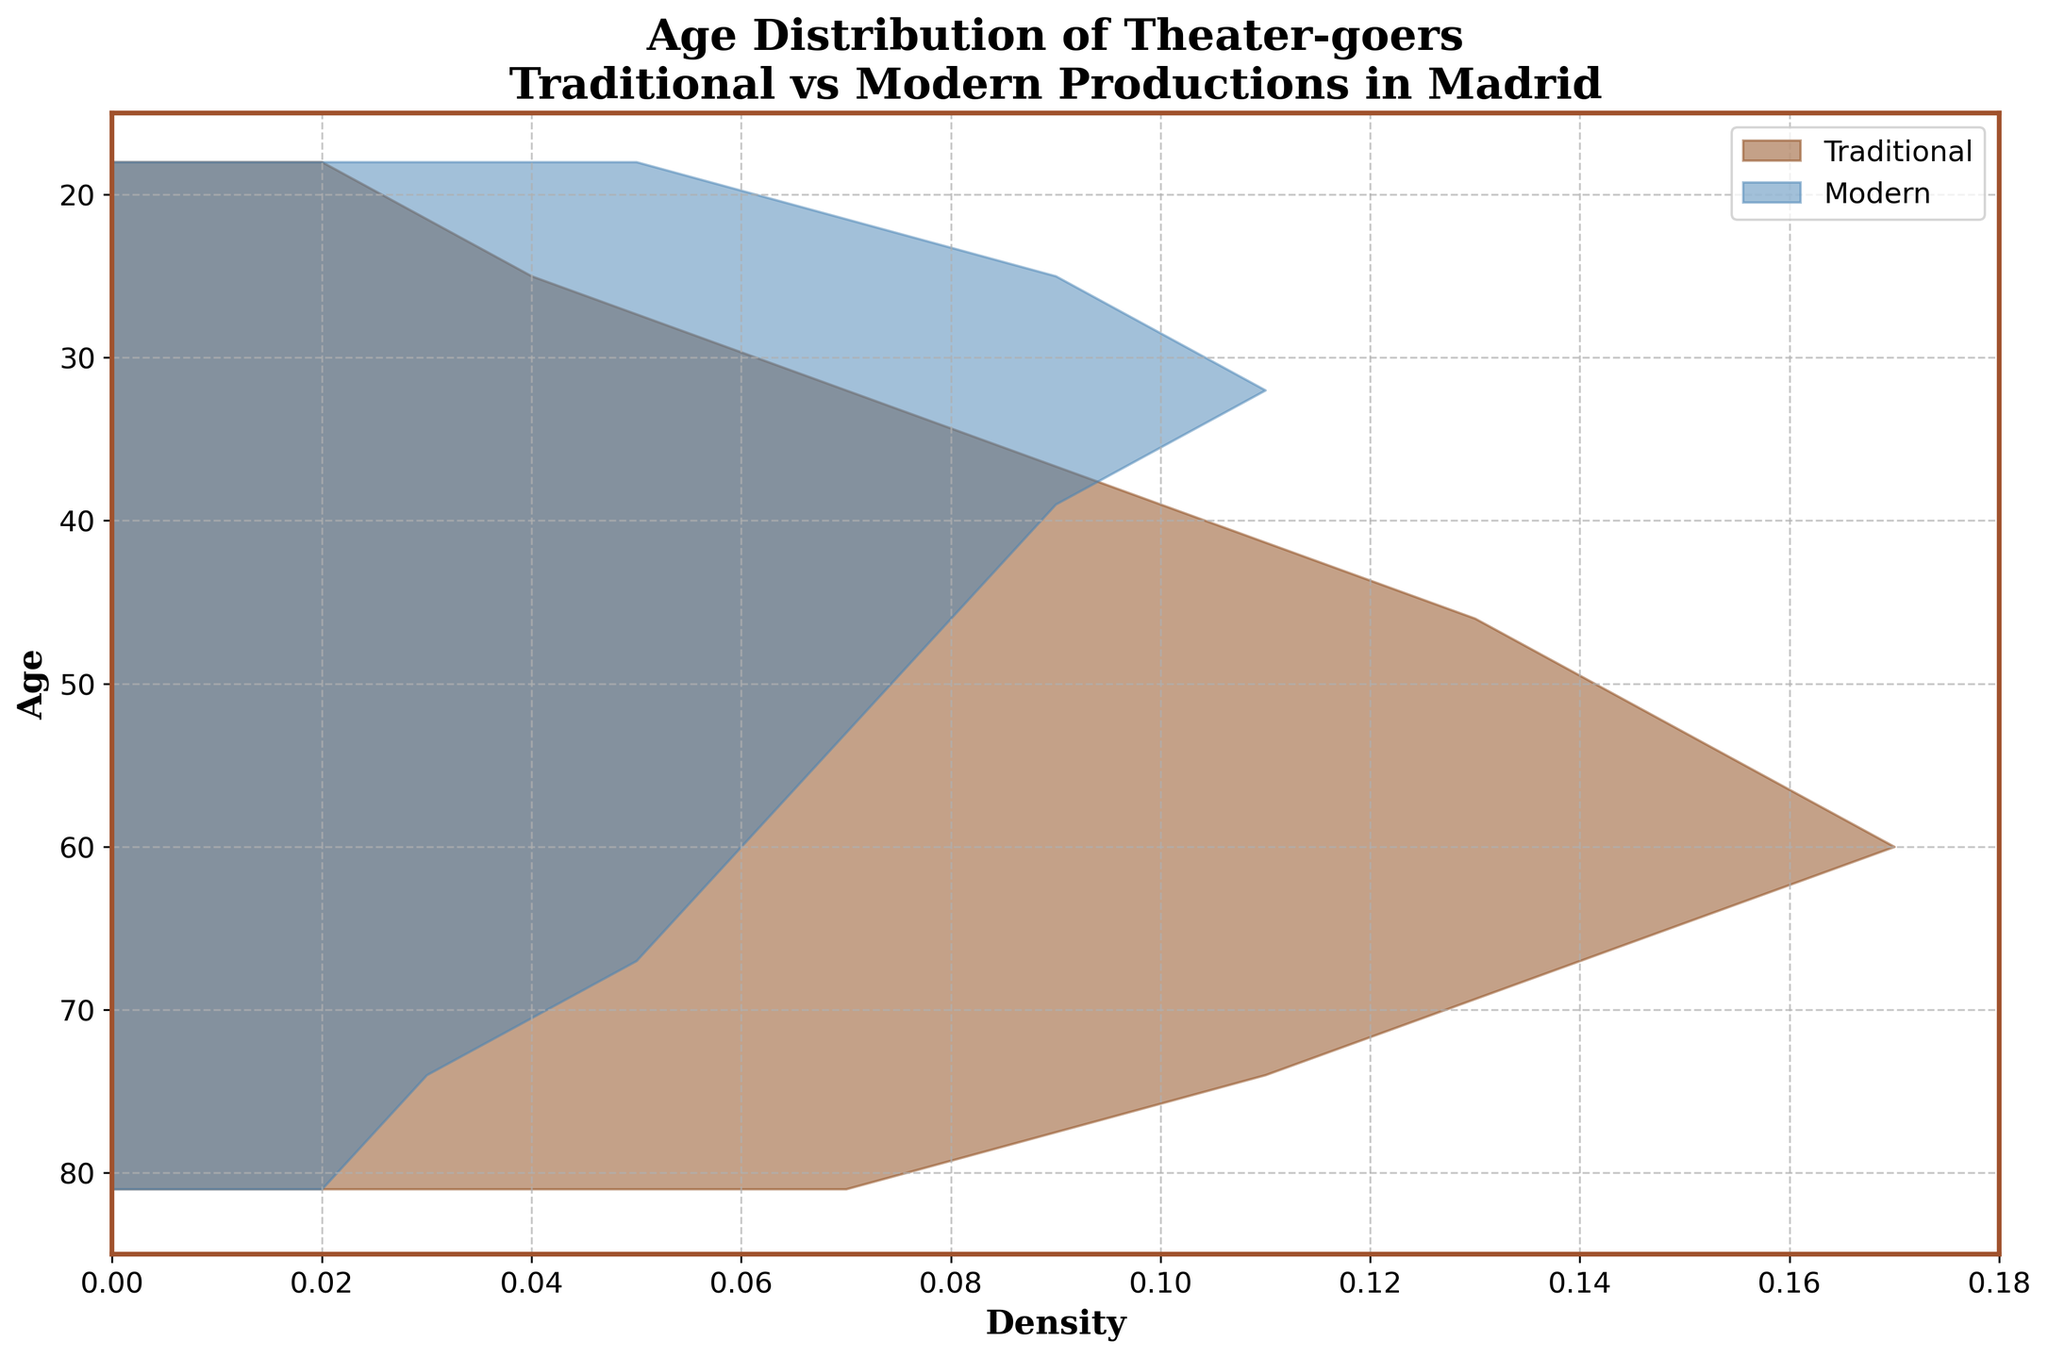What is the title of the plot? The title of the plot is found at the top and provides a summary of what the plot represents.
Answer: Age Distribution of Theater-goers Traditional vs Modern Productions in Madrid What is the overall age range represented in the plot? The y-axis represents the ages, and the plot limits the ages from 18 to 81.
Answer: 18 to 81 Which age group shows the highest density for traditional productions? By looking at the peaks for the traditional density (brown color), the highest density is at age 60.
Answer: 60 At what age does the density for modern productions begin to decline? Looking at the modern density (blue color), it begins to decline after peaking around age 32.
Answer: 32 How do densities for traditional and modern productions compare at age 25? At age 25, the modern density (blue) is higher than the traditional density (brown).
Answer: Modern is higher Is there any age group where the density for traditional and modern productions is equal? Examining the plot, there are no precise age groups where the densities are exactly equal.
Answer: No Between ages 53 and 60, which production type shows more stability in density? The traditional density (brown) remains stable or increases slightly, while the modern density (blue) decreases.
Answer: Traditional What is the average density of theater-goers for modern productions between ages 18 and 81? Sum the individual densities for modern productions (0.05 + 0.09 + 0.11 + 0.09 + 0.08 + 0.07 + 0.06 + 0.05 + 0.03 + 0.02) which equals 0.55. Divide by the number of ages (10).
Answer: 0.055 What age group has the biggest difference in density between traditional and modern productions? Comparing the differences, the largest difference is at age 60 where traditional is 0.17 and modern is 0.06, resulting in a difference of 0.11.
Answer: 60 How does the age group 67 compare in terms of traditional versus modern theater-goers? At age 67, the density for traditional productions is much higher than modern (traditional 0.14 versus modern 0.05).
Answer: Traditional is higher 